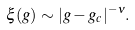<formula> <loc_0><loc_0><loc_500><loc_500>\xi ( g ) \sim | g - g _ { c } | ^ { - \nu } .</formula> 